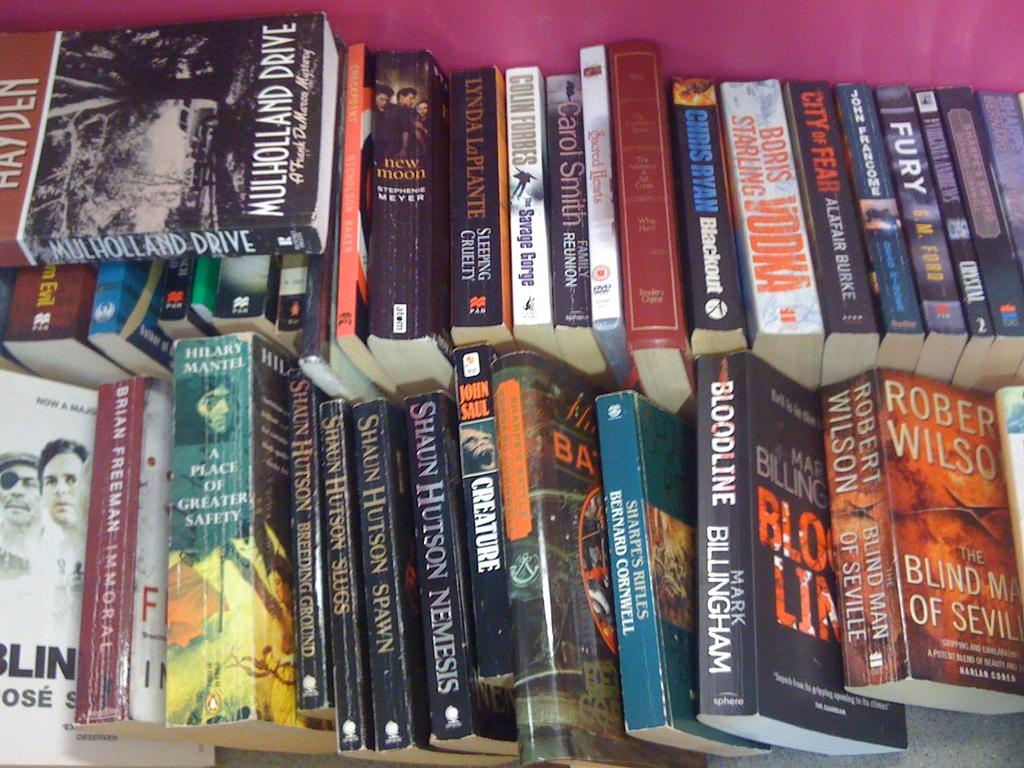Do they have the book :bloodline" in here?
Keep it short and to the point. Yes. 